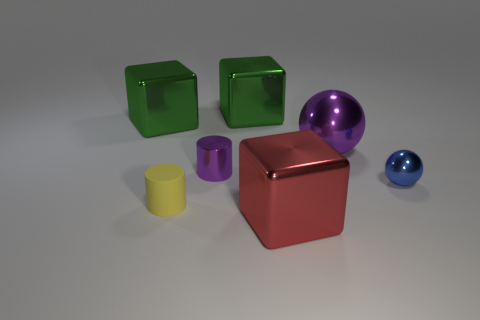Are there shadows present for every object, and what can they tell us about the light source? Yes, every object casts a visible shadow, indicating a single light source positioned above and slightly to the right of the scene, creating soft-edged shadows on the left side of the objects.  Could you compare the textures of the objects? The surfaces of all objects look uniformly smooth and glossy, lacking any visible texture, which emphasizes their reflective quality. 